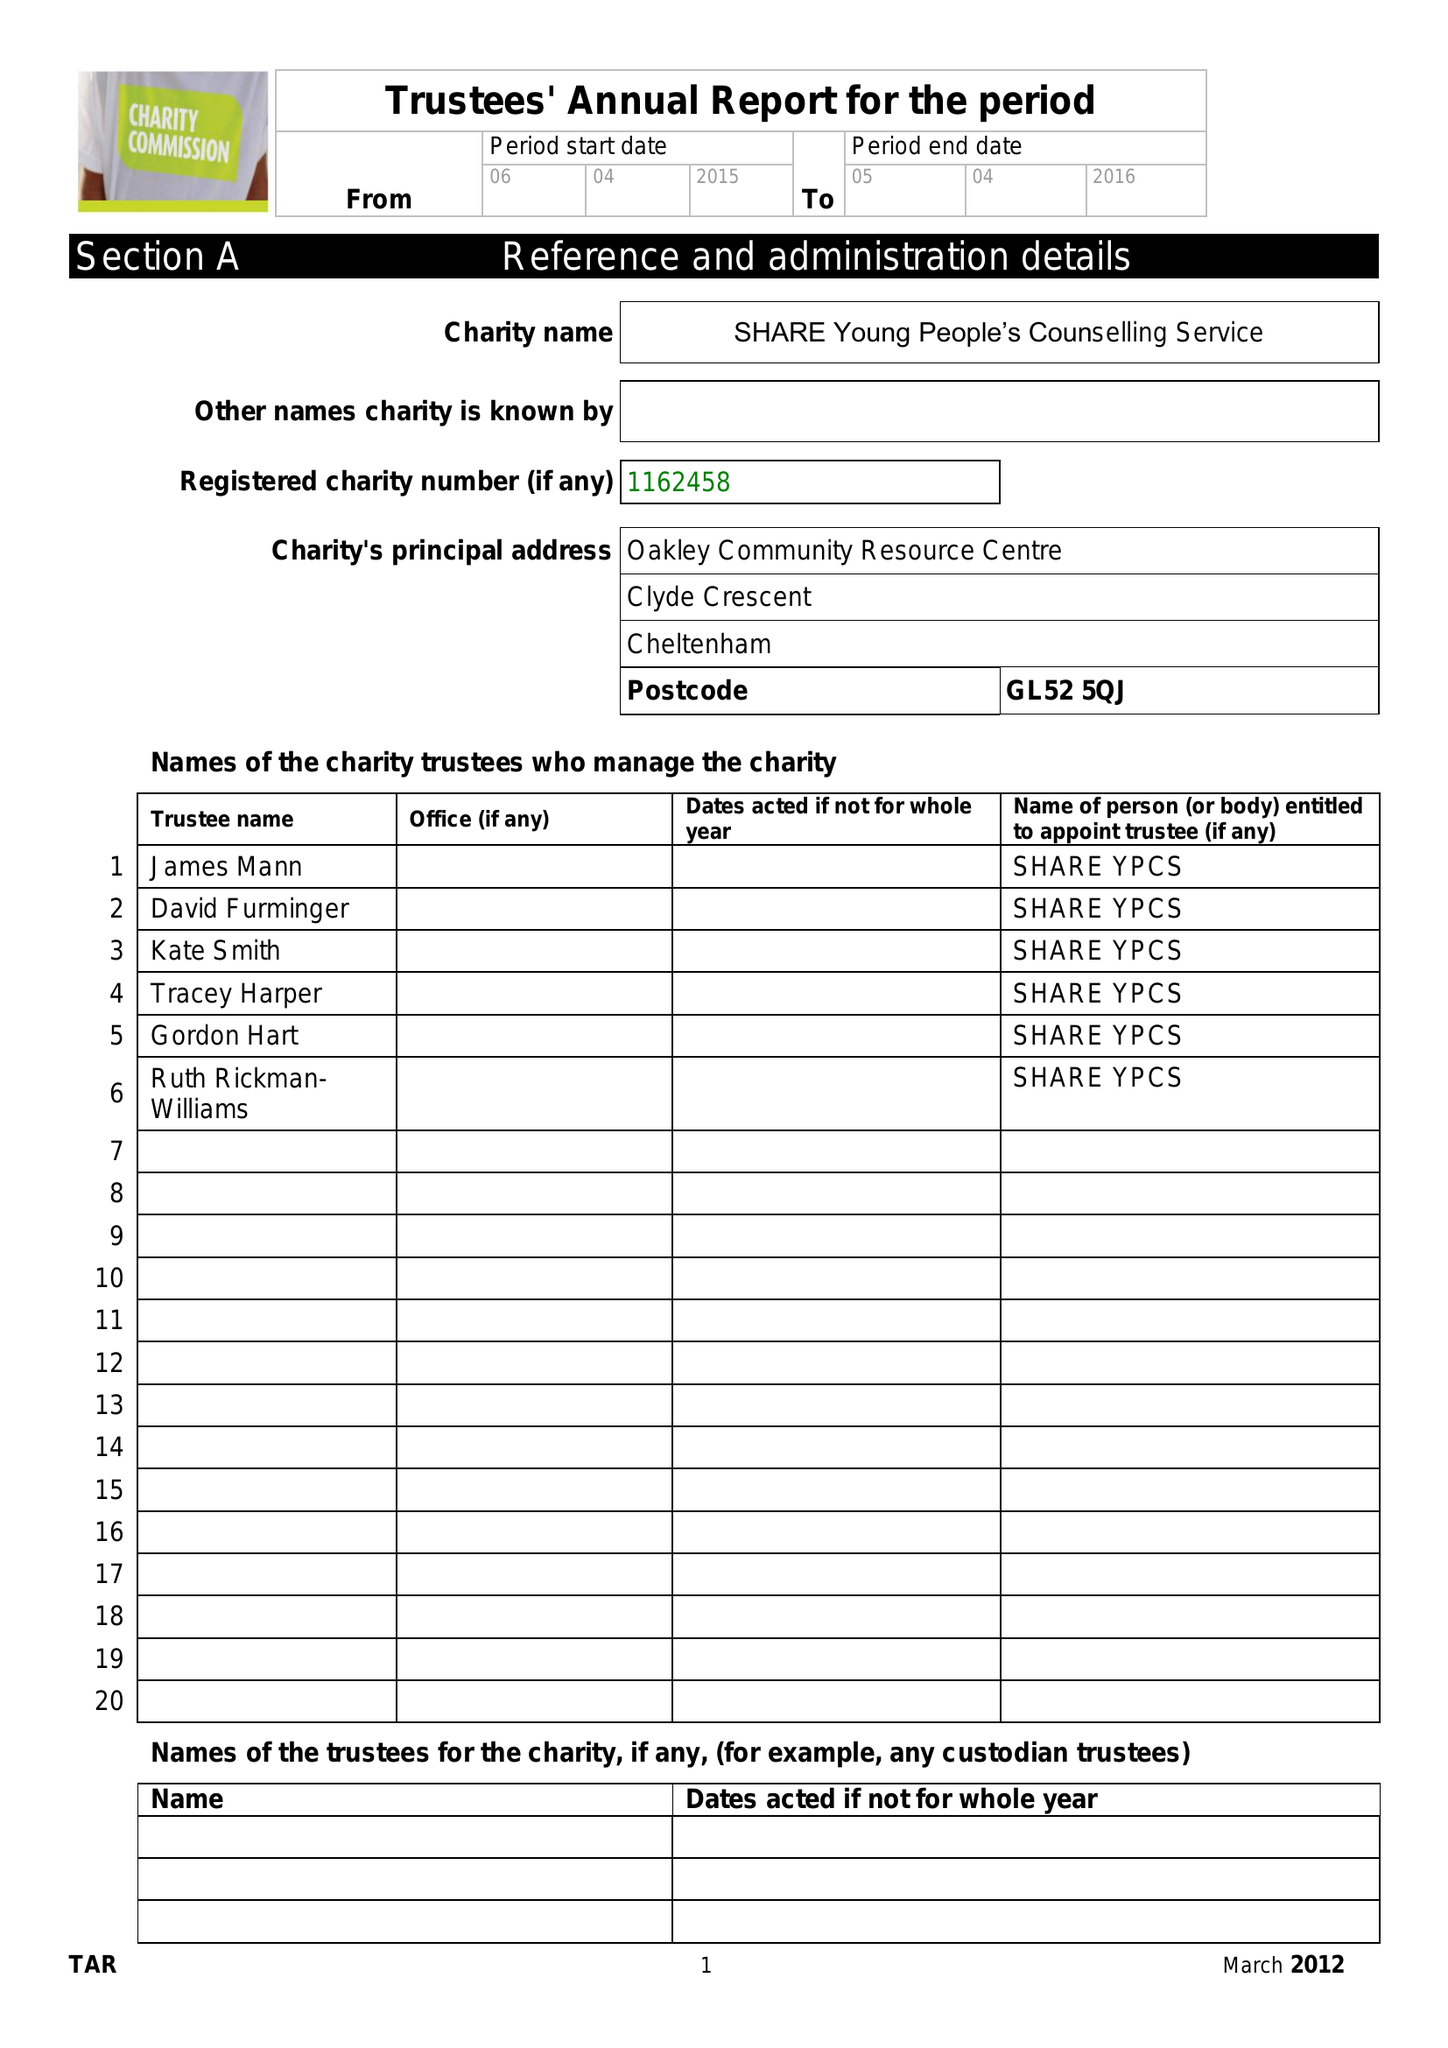What is the value for the charity_name?
Answer the question using a single word or phrase. Share Young People's Counselling Service 